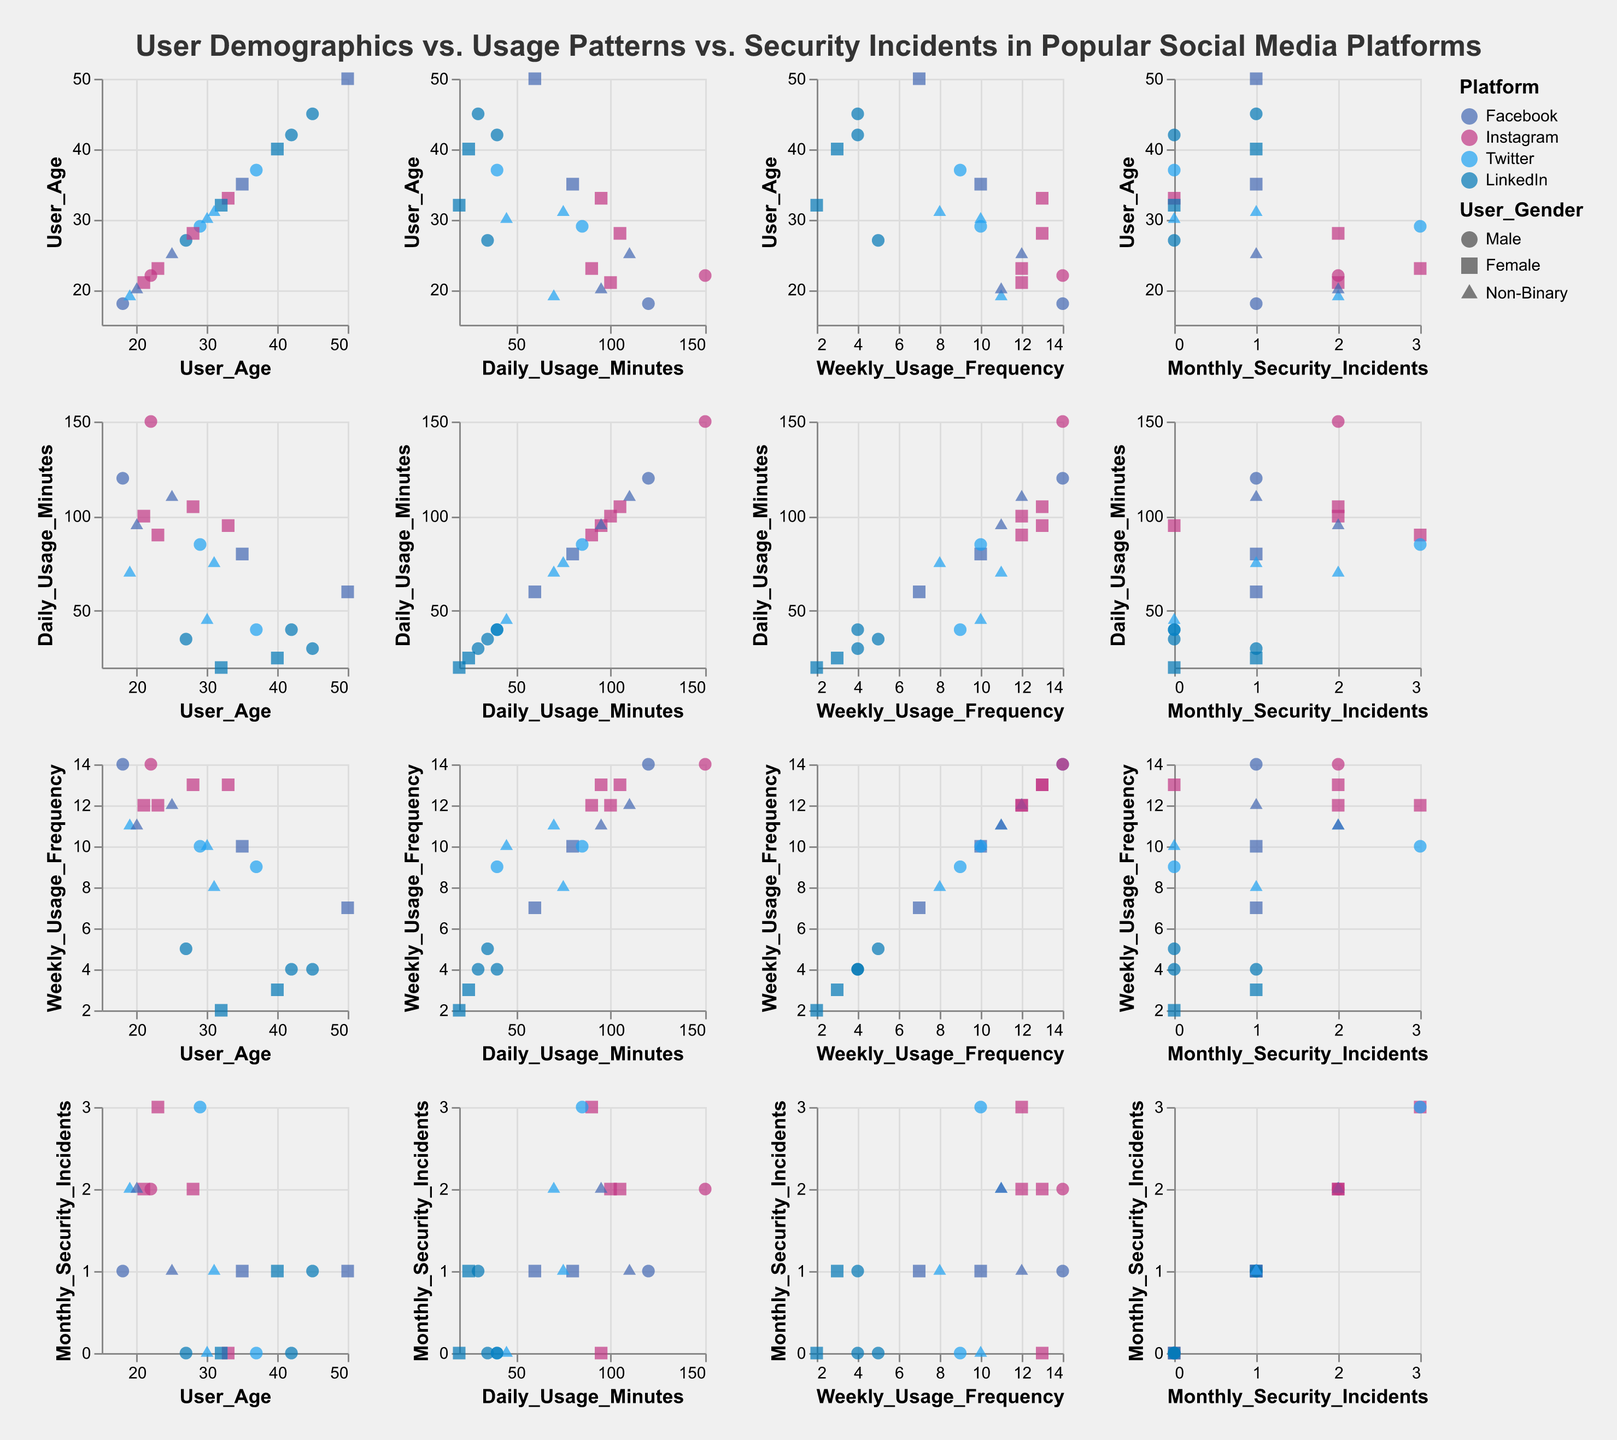What is the title of the figure? The title of the figure is presented at the top in bold font. It summarizes the subject of the plot, indicating it is about user demographics, usage patterns, and security incidents in popular social media platforms.
Answer: User Demographics vs. Usage Patterns vs. Security Incidents in Popular Social Media Platforms What colors represent the different platforms? The visual representation uses distinct colors for each platform: Facebook is blue, Instagram is pink, Twitter is light blue, and LinkedIn is dark blue.
Answer: Facebook (blue), Instagram (pink), Twitter (light blue), LinkedIn (dark blue) How many data points represent Male users using Facebook? To determine this, locate the blue-colored circles in the scatter plot matrix where the shape represents Male users. This specific shape is a circle colored in blue. Then simply count these data points.
Answer: 3 Which platform has the highest daily usage minutes on average? Compare the daily usage minutes across all data points for each platform. Sum the total and then calculate the average for each platform. The highest average will determine the platform with the highest daily usage minutes.
Answer: Instagram Is there any apparent relationship between user age and daily usage minutes? To detect this, observe the scatter plot in the matrix where User Age and Daily Usage Minutes are plotted against each other. Look for any trends such as positive, negative, or no correlation. Analyze whether older users spend more or less time daily on average compared to younger users.
Answer: No clear correlation How many monthly security incidents do Instagram users face compared to Twitter users? Compare the data points representing 'Monthly Security Incidents' for both platforms. Count Instagram and Twitter data points to determine the respective number of security incidents.
Answer: Instagram: 8 incidents; Twitter: 6 incidents Which user group (by gender) has the lowest weekly usage frequency on LinkedIn? Check the scatter plots corresponding to LinkedIn users. Identify the shapes representing different genders and compare their ‘Weekly Usage Frequency’ values to find the lowest one.
Answer: Female Do older users generally face more security incidents than younger users? Observe the plots involving 'User Age' versus 'Monthly Security Incidents'. By comparing the age groups and their corresponding incidents, one can judge if there is a visible trend indicating older users face more incidents.
Answer: No clear trend Which data points represent the youngest Instagram user and the number of their monthly security incidents? Identify the Instagram users by the pink-colored data points. Look for the youngest age among these data points and then note their corresponding value in the 'Monthly Security Incidents' axis.
Answer: Age 21, 2 incidents Is there any gender that shows higher daily usage on Twitter compared to other genders? By examining the shapes representing different genders and their corresponding daily usage minutes specifically for the platform Twitter, compare the values to determine if any gender has higher usage.
Answer: No discernible pattern 